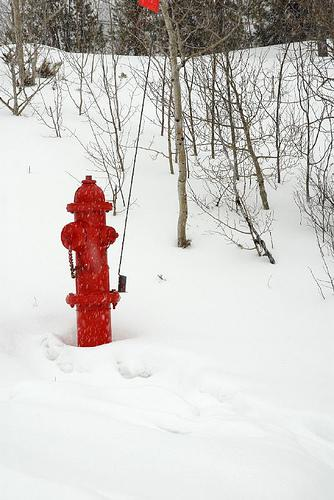Question: when was the picture taken?
Choices:
A. In the summer.
B. During the day.
C. During the winter.
D. At night.
Answer with the letter. Answer: C Question: where was the picture taken?
Choices:
A. At the mall.
B. In the house.
C. In school.
D. The outdoors.
Answer with the letter. Answer: D Question: what color are the trees?
Choices:
A. Green.
B. Red.
C. Brown.
D. White.
Answer with the letter. Answer: C Question: what color is the fire hydrant?
Choices:
A. Blue.
B. White.
C. Red.
D. Black.
Answer with the letter. Answer: C Question: what is on the ground?
Choices:
A. Dirt.
B. Sand.
C. Snow.
D. Concrete.
Answer with the letter. Answer: C 